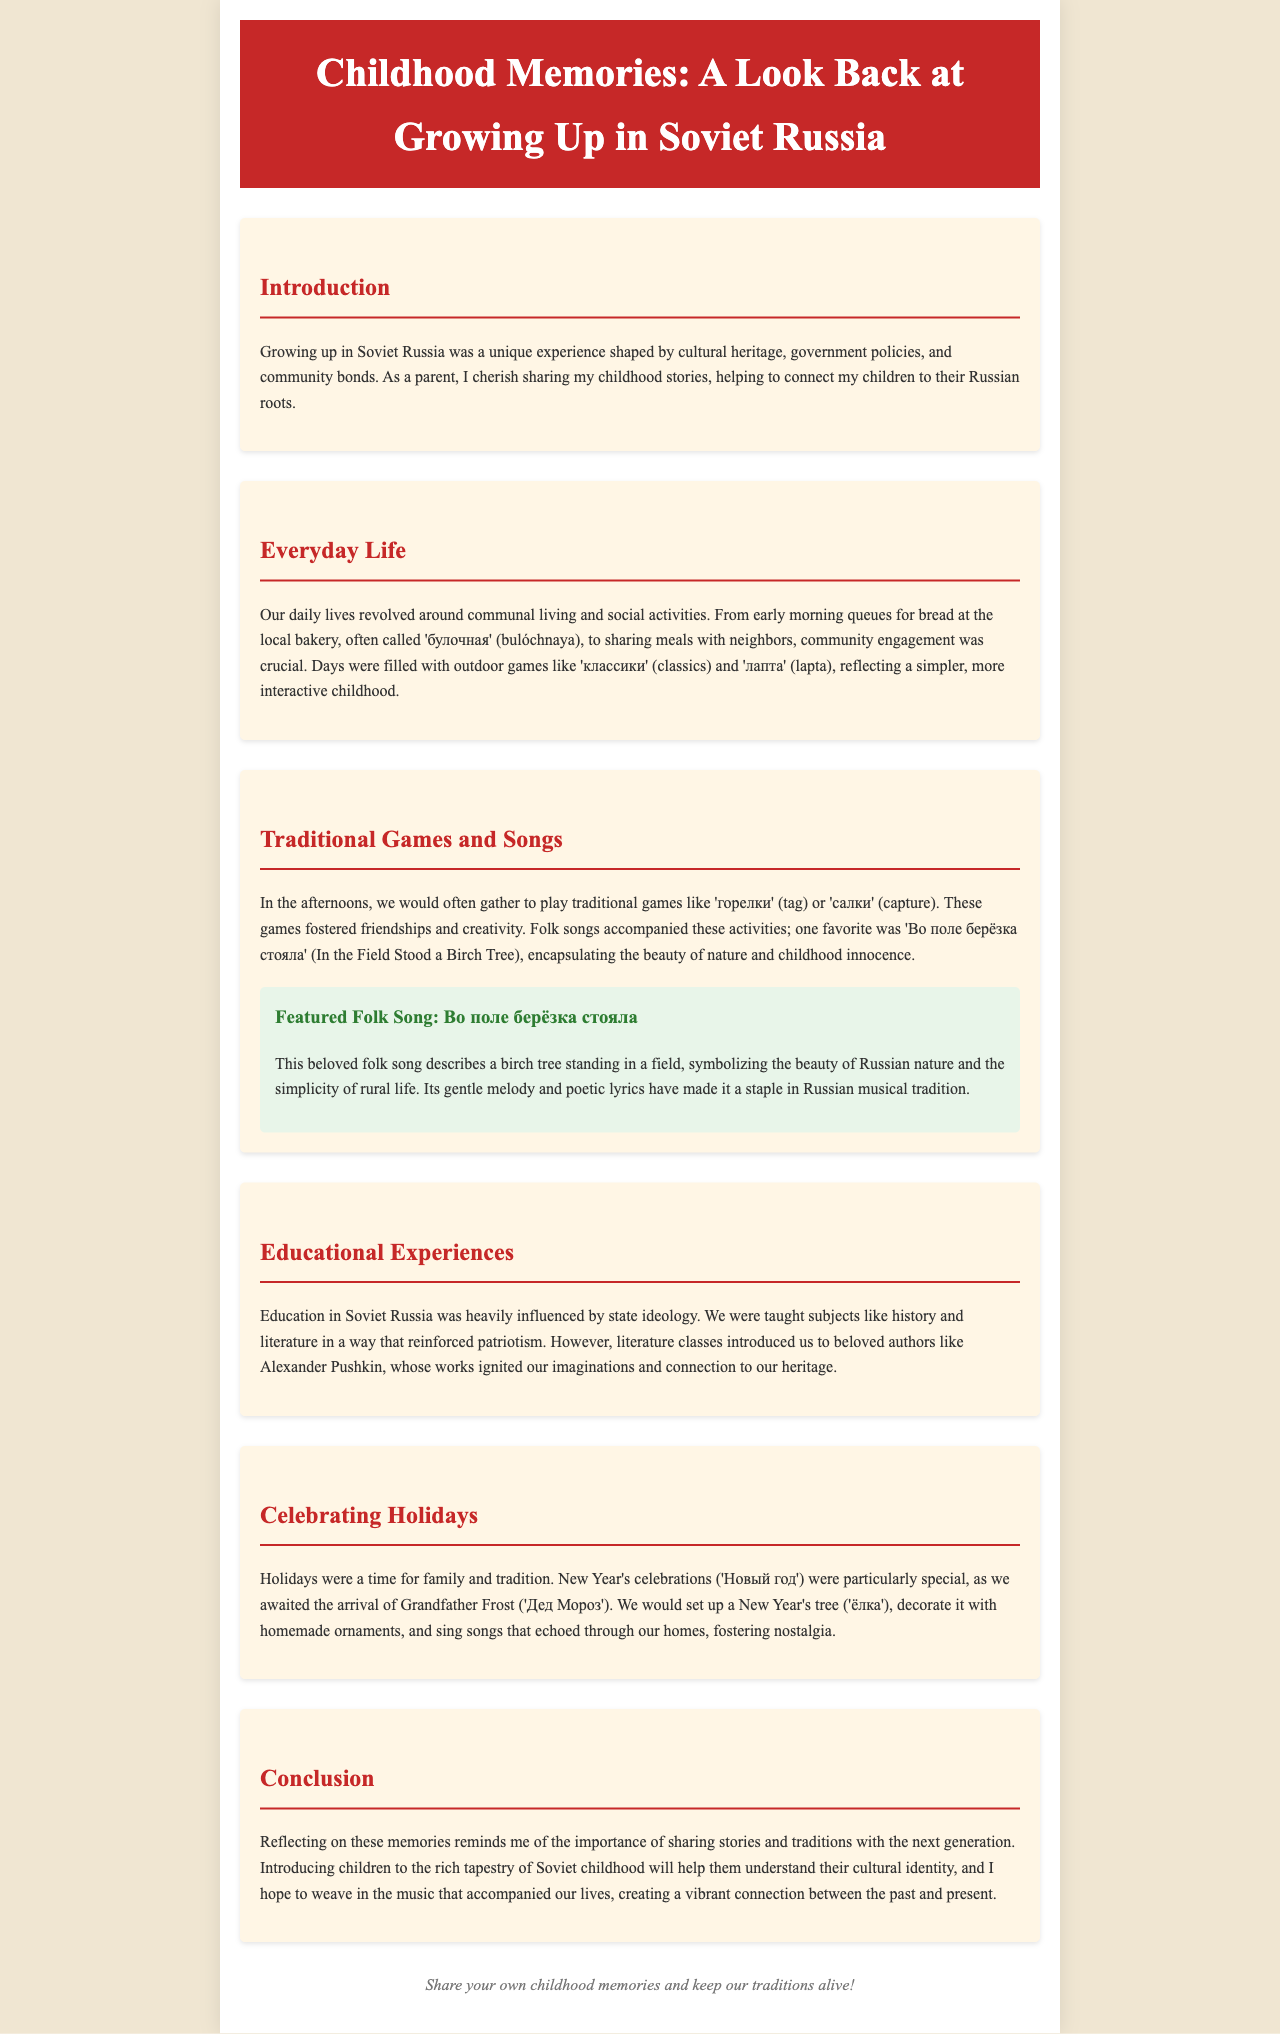What is the title of the newsletter? The title is the main heading displayed at the top of the document, which summarizes the content of the newsletter.
Answer: Childhood Memories: A Look Back at Growing Up in Soviet Russia What game is mentioned as played during childhood? The document mentions specific games that were popular during childhood in Soviet Russia, highlighting communal and social activities.
Answer: лапта Which folk song is featured in the document? The folk song is highlighted as a significant piece of music that reflects childhood experiences and cultural heritage.
Answer: Во поле берёзка стояла What significant holiday is discussed in the newsletter? The newsletter describes cultural practices during a specific celebration that is unique to Russian traditions.
Answer: Новый год What was a common activity in the mornings mentioned in everyday life? The document details daily routines that shaped the experiences of children growing up in a specific cultural context in Soviet Russia.
Answer: queues for bread What is mentioned as a strong influence on education in Soviet Russia? The document notes an important concept that guided educational practices and subject matter in schools during that era.
Answer: state ideology Which author is mentioned in connection to literature classes? The newsletter refers to a notable literary figure whose works were important in the educational experience of children.
Answer: Alexander Pushkin What is highlighted as a way to connect children to their Russian roots? The document emphasizes a particular activity that helps instill cultural identity and heritage in the next generation.
Answer: sharing stories 